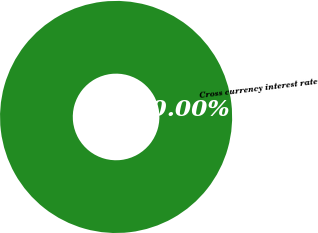Convert chart to OTSL. <chart><loc_0><loc_0><loc_500><loc_500><pie_chart><fcel>Cross currency interest rate<nl><fcel>100.0%<nl></chart> 